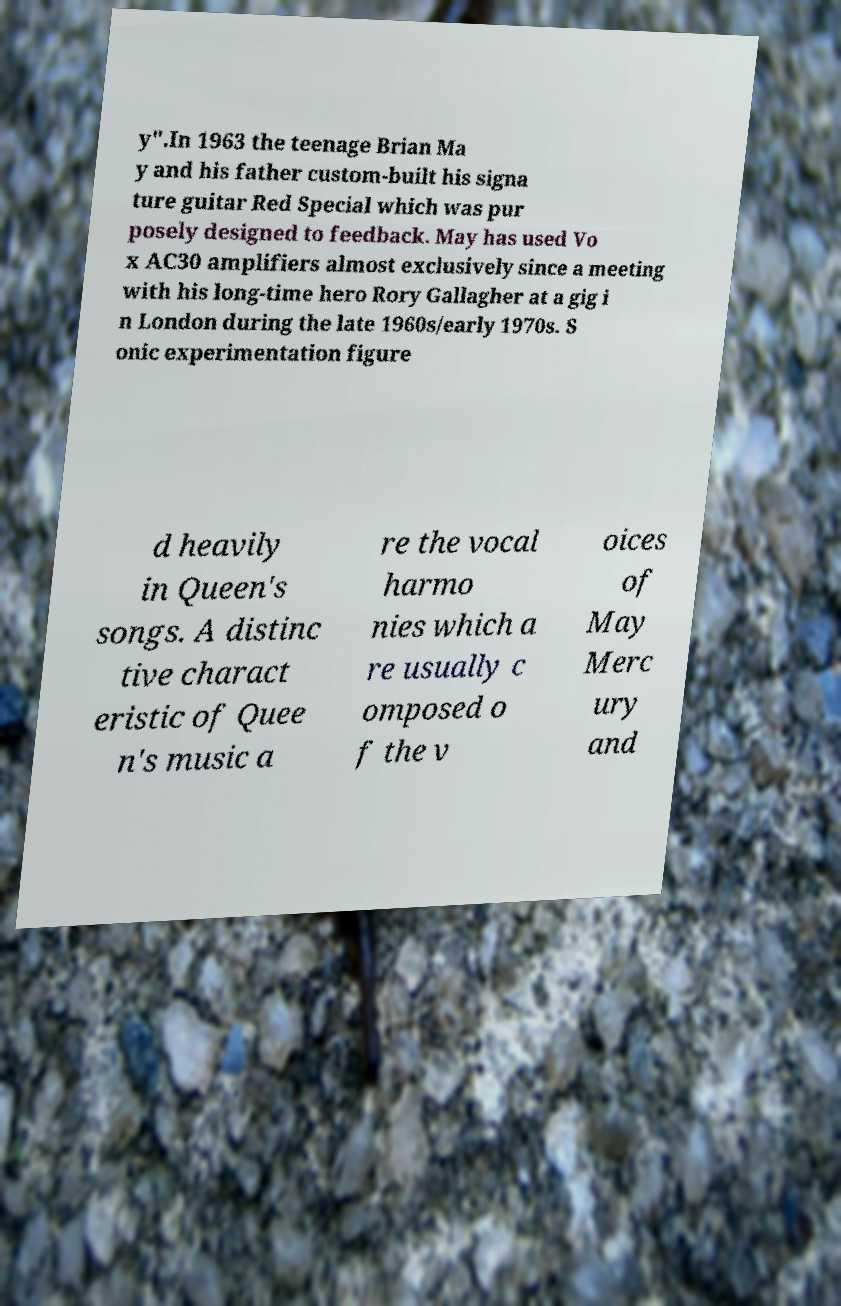Could you assist in decoding the text presented in this image and type it out clearly? y".In 1963 the teenage Brian Ma y and his father custom-built his signa ture guitar Red Special which was pur posely designed to feedback. May has used Vo x AC30 amplifiers almost exclusively since a meeting with his long-time hero Rory Gallagher at a gig i n London during the late 1960s/early 1970s. S onic experimentation figure d heavily in Queen's songs. A distinc tive charact eristic of Quee n's music a re the vocal harmo nies which a re usually c omposed o f the v oices of May Merc ury and 